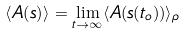Convert formula to latex. <formula><loc_0><loc_0><loc_500><loc_500>\langle A ( { s } ) \rangle = \lim _ { t \rightarrow \infty } \langle A ( { s } ( t _ { o } ) ) \rangle _ { \rho }</formula> 